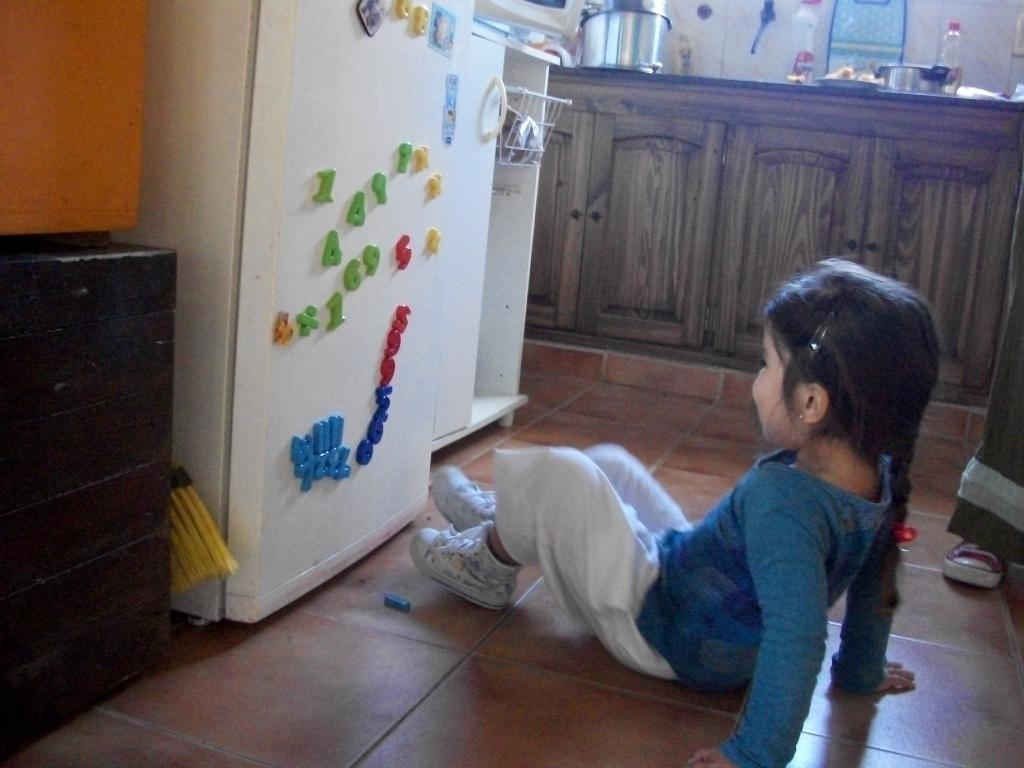Provide a one-sentence caption for the provided image. A little girl sits in front of a fridge with 4, 4, 1, X and X magnets on it. 